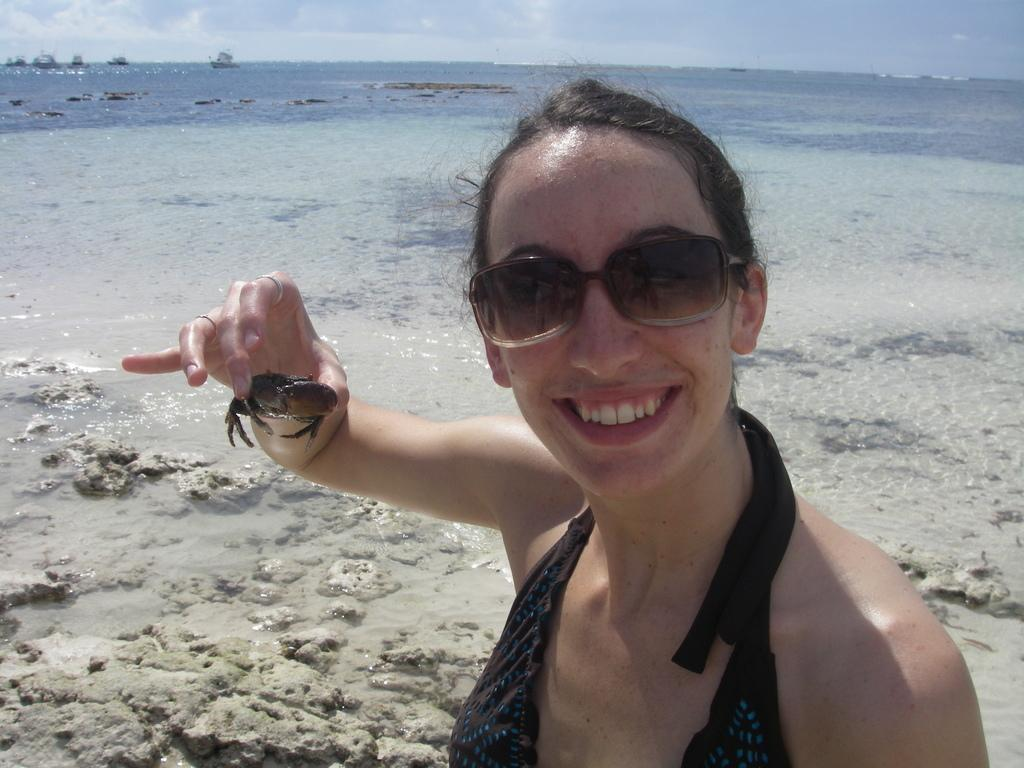Who is present in the image? There is a woman in the image. What is the woman wearing? The woman is wearing a black dress and spectacles. What is the woman holding in the image? The woman is holding a crab. What can be seen in the background of the image? There is an ocean and the sky visible in the background of the image. What type of jeans is the woman wearing in the image? The woman is not wearing jeans in the image; she is wearing a black dress. How many trucks can be seen in the image? There are no trucks present in the image. 